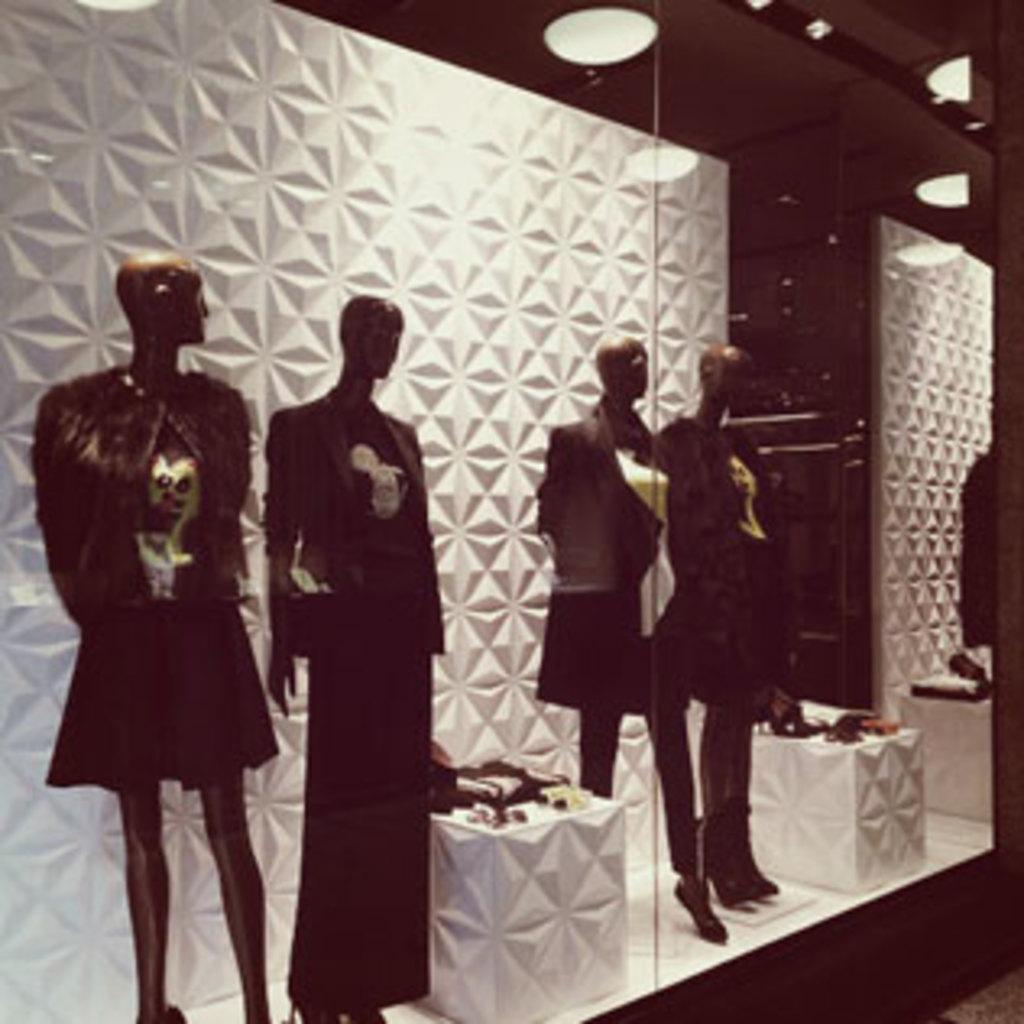How many mannequins are in the image? There are four mannequins in the image. What are the mannequins wearing? The mannequins are wearing dresses. What can be seen on the stools in the image? There are items on stools in the image. What can be seen illuminating the scene in the image? There are lights visible in the image. What type of account is being exchanged between the mannequins in the image? There is no exchange of accounts or any financial transactions taking place in the image, as it features mannequins wearing dresses and other items on stools. 